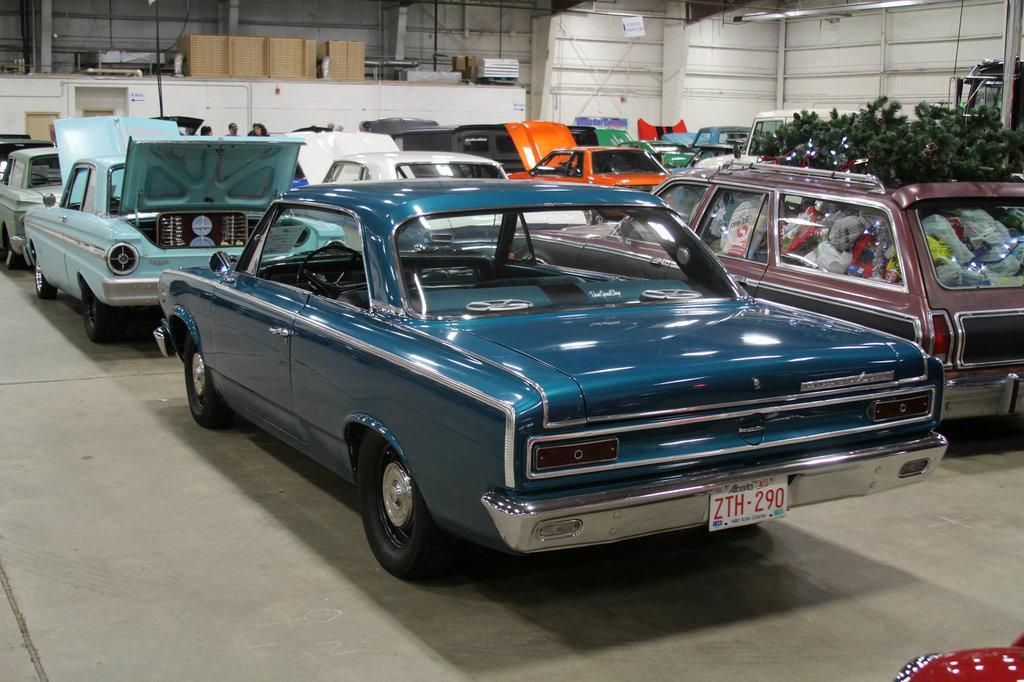Can you describe this image briefly? In this image I can see a car which is blue in color on the ground and to the right side of the image I can see another car which is red in color and in the car I can see few plants and few other objects. In the background I can see number of cars, the white colored wall and few other objects. 